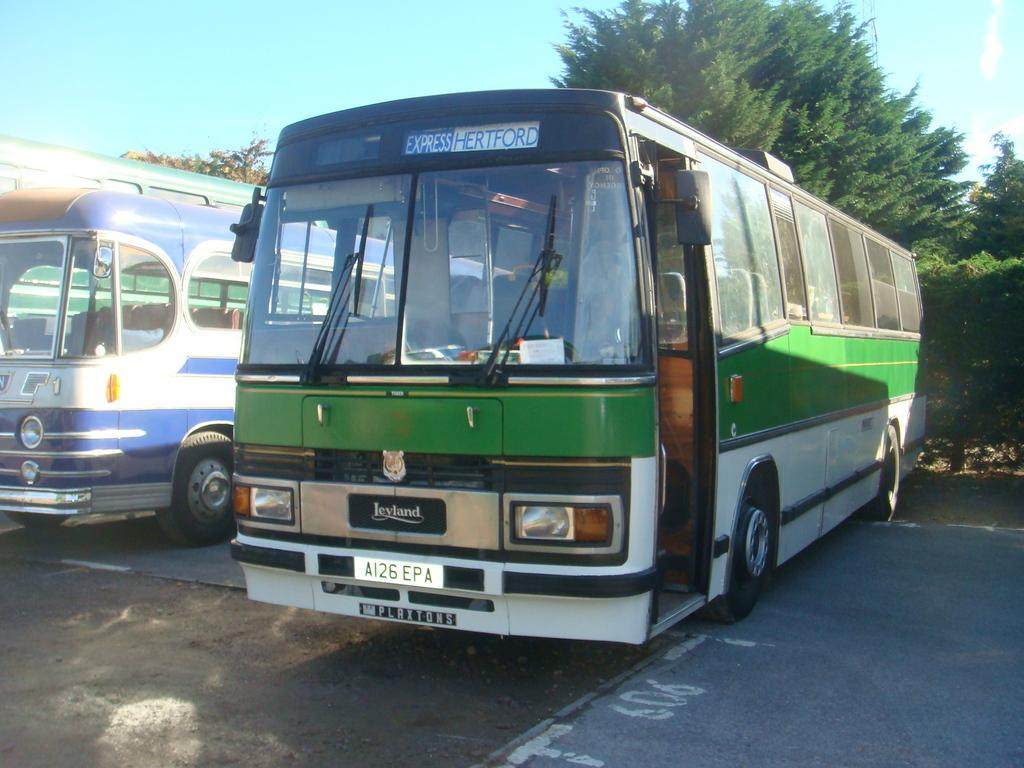<image>
Share a concise interpretation of the image provided. A bus with Express Hartford on the front. 